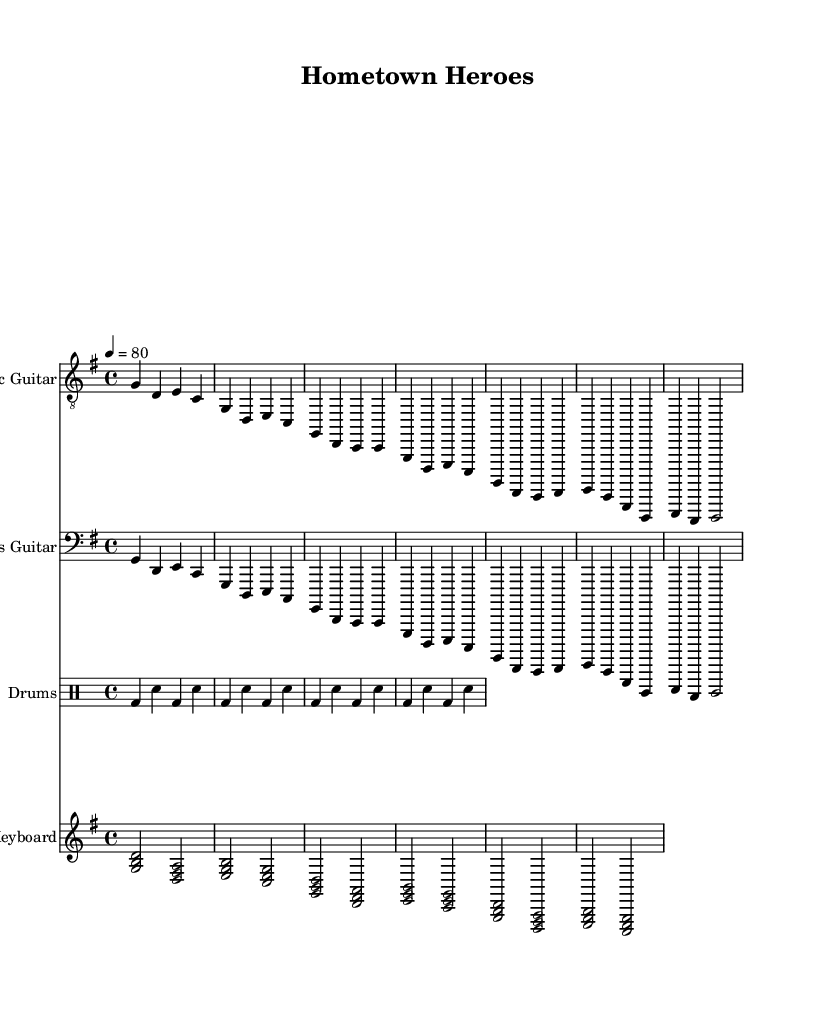What is the key signature of this music? The key signature is G major, which has one sharp (F#). This can be identified in the music sheet by looking at the key signature at the beginning of the staff.
Answer: G major What is the time signature of this music? The time signature is 4/4, which means there are four beats in each measure. This is indicated at the beginning of the sheet music.
Answer: 4/4 What is the tempo marking for this piece? The tempo marking indicates a speed of 80 beats per minute. This is commonly found at the beginning of the score, showing the intended speed for the performance.
Answer: 80 How many measures are in the chorus section? The chorus consists of four measures. By examining the notation for the chorus, one can count the distinct measures to arrive at the total.
Answer: 4 What style of music is represented in this sheet? The style is rock, indicated by the instrumentation and rhythmic patterns typical of rock music. The use of electric guitar, bass guitar, drums, and a keyboard further cements this classification.
Answer: Rock What is the main theme of this composition? The main theme is community service and heroism, which can be inferred from the title "Hometown Heroes" and the context of the lyrics typical in rock ballads focusing on these themes.
Answer: Community service and heroism 